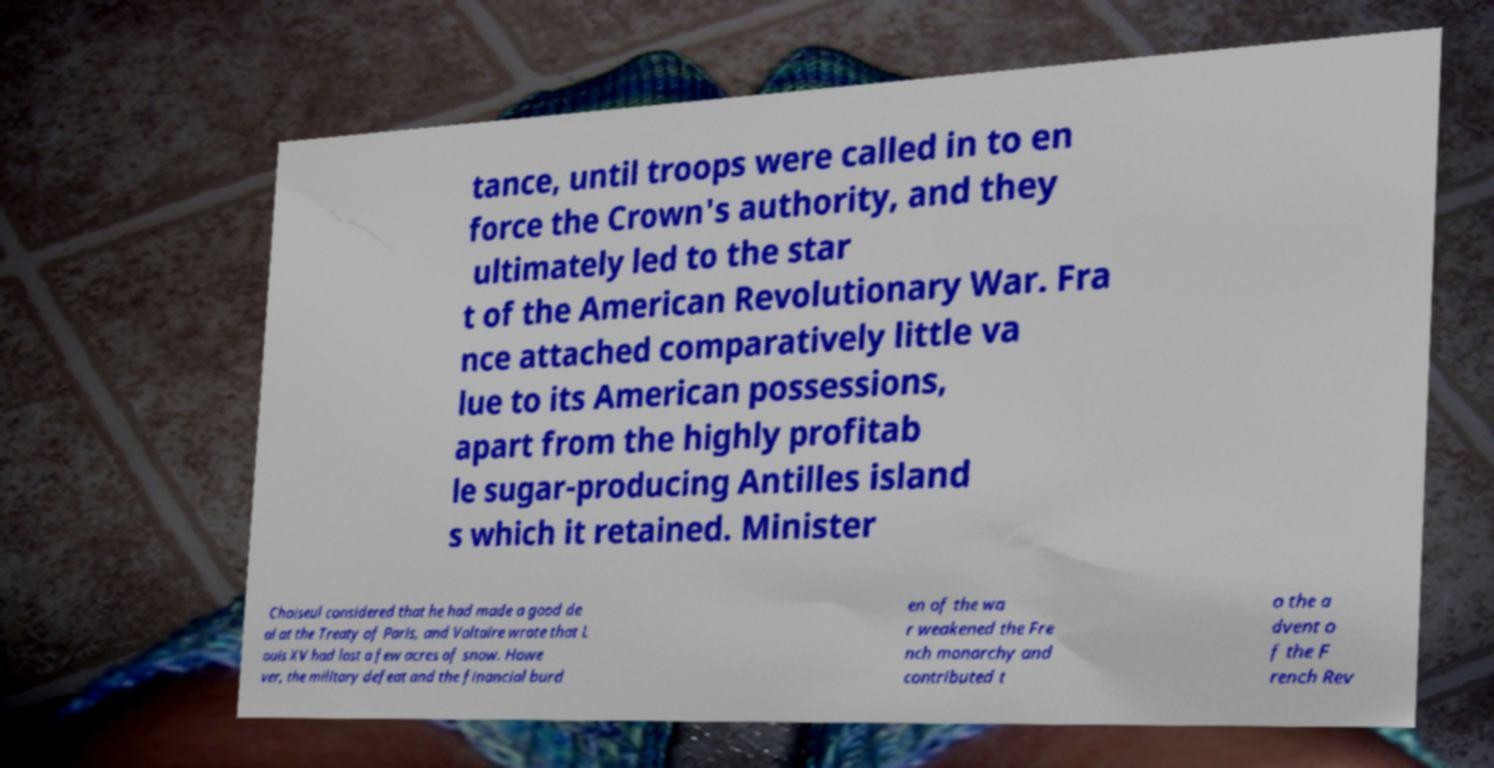There's text embedded in this image that I need extracted. Can you transcribe it verbatim? tance, until troops were called in to en force the Crown's authority, and they ultimately led to the star t of the American Revolutionary War. Fra nce attached comparatively little va lue to its American possessions, apart from the highly profitab le sugar-producing Antilles island s which it retained. Minister Choiseul considered that he had made a good de al at the Treaty of Paris, and Voltaire wrote that L ouis XV had lost a few acres of snow. Howe ver, the military defeat and the financial burd en of the wa r weakened the Fre nch monarchy and contributed t o the a dvent o f the F rench Rev 